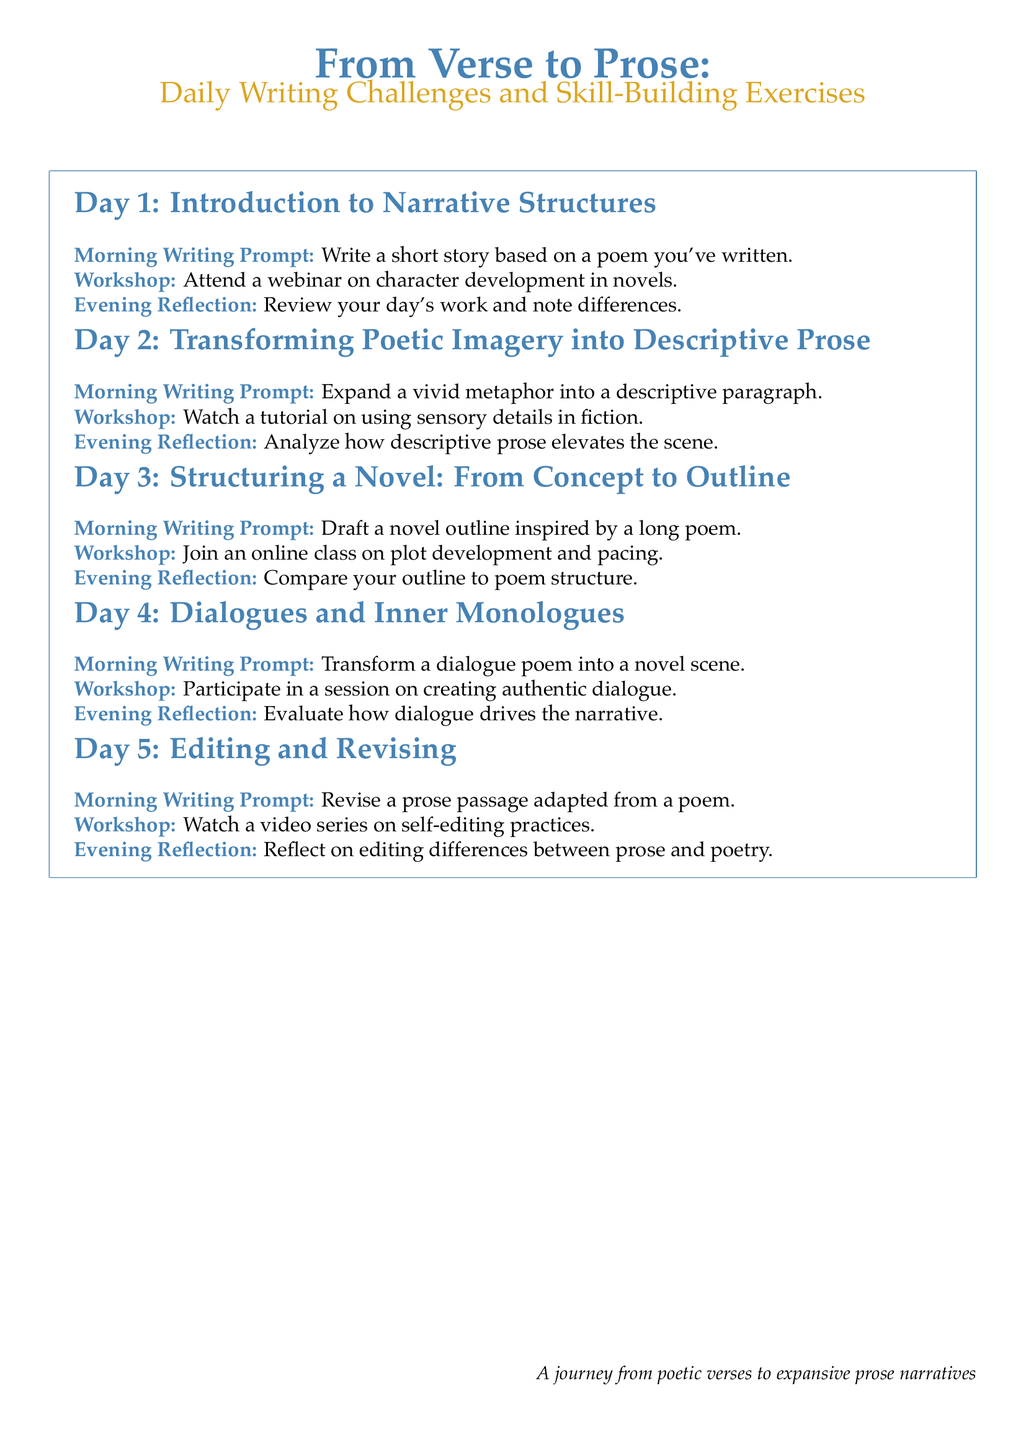What is the title of the document? The title is presented at the top of the document, highlighting the focus on transitioning from poetry to prose.
Answer: From Verse to Prose How many days are outlined in the itinerary? The itinerary clearly lists activities for five distinct days.
Answer: 5 What type of writing prompt is given on Day 1? The writing prompt for Day 1 is specified as a short story based on a poem.
Answer: Write a short story based on a poem you've written What workshop is scheduled for Day 2? The workshop mentioned for Day 2 focuses on enhancing descriptive skills in writing.
Answer: Watch a tutorial on using sensory details in fiction What is the main focus of the activities on Day 3? Day 3 activities are centered around creating a structured outline for a novel.
Answer: Structuring a Novel: From Concept to Outline How does the document categorize the daily activities? The daily activities are categorized into distinct segments such as Morning Writing Prompt, Workshop, and Evening Reflection.
Answer: Morning Writing Prompt, Workshop, Evening Reflection What is emphasized in the Evening Reflection for Day 5? The Evening Reflection for Day 5 highlights differences in the editing process between formats of writing.
Answer: Reflect on editing differences between prose and poetry What type of content does the document include to support learning? The document includes workshops, writing prompts, and reflective exercises to facilitate skill-building.
Answer: Workshops, writing prompts, reflective exercises 